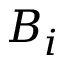Convert formula to latex. <formula><loc_0><loc_0><loc_500><loc_500>B _ { i }</formula> 